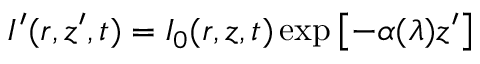Convert formula to latex. <formula><loc_0><loc_0><loc_500><loc_500>I ^ { \prime } ( r , z ^ { \prime } , t ) = I _ { 0 } ( r , z , t ) \exp \left [ - \alpha ( \lambda ) z ^ { \prime } \right ]</formula> 